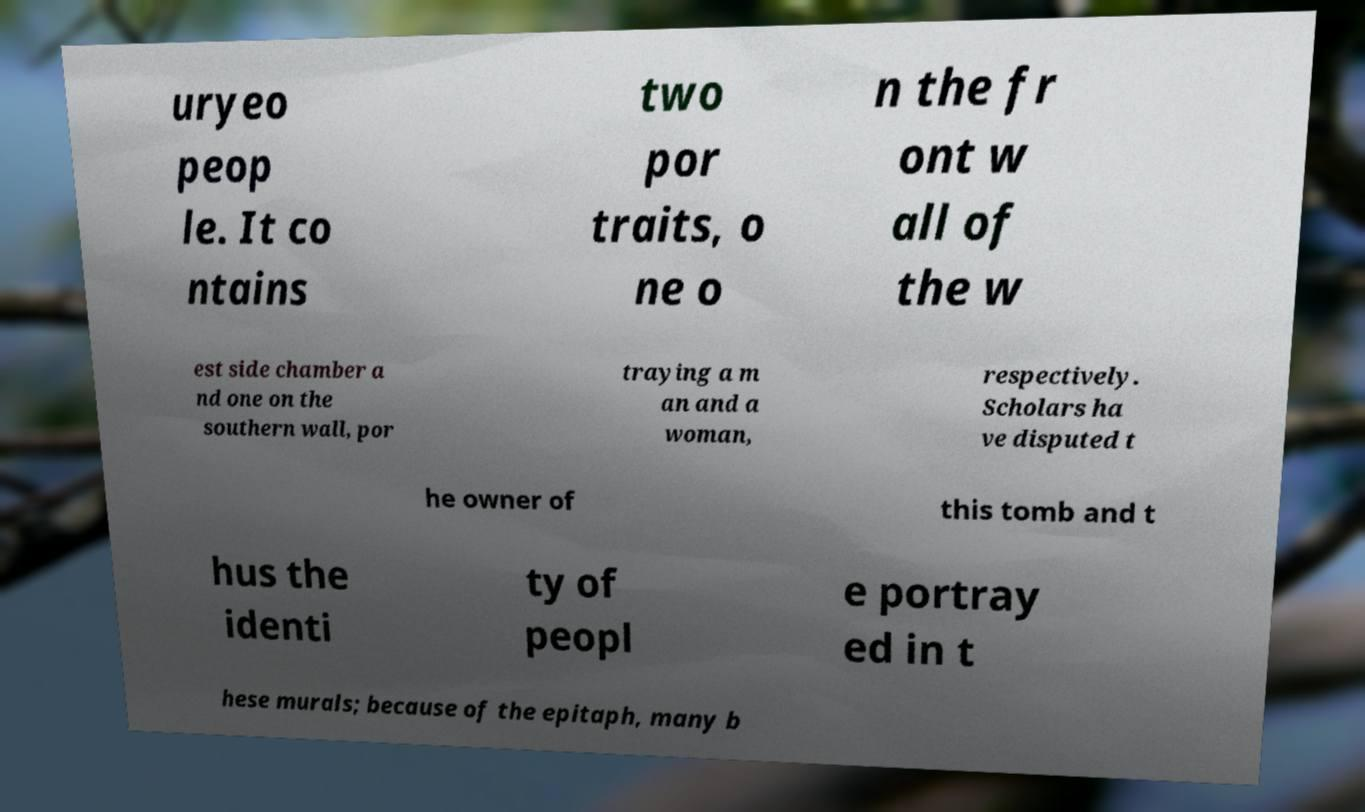Could you extract and type out the text from this image? uryeo peop le. It co ntains two por traits, o ne o n the fr ont w all of the w est side chamber a nd one on the southern wall, por traying a m an and a woman, respectively. Scholars ha ve disputed t he owner of this tomb and t hus the identi ty of peopl e portray ed in t hese murals; because of the epitaph, many b 